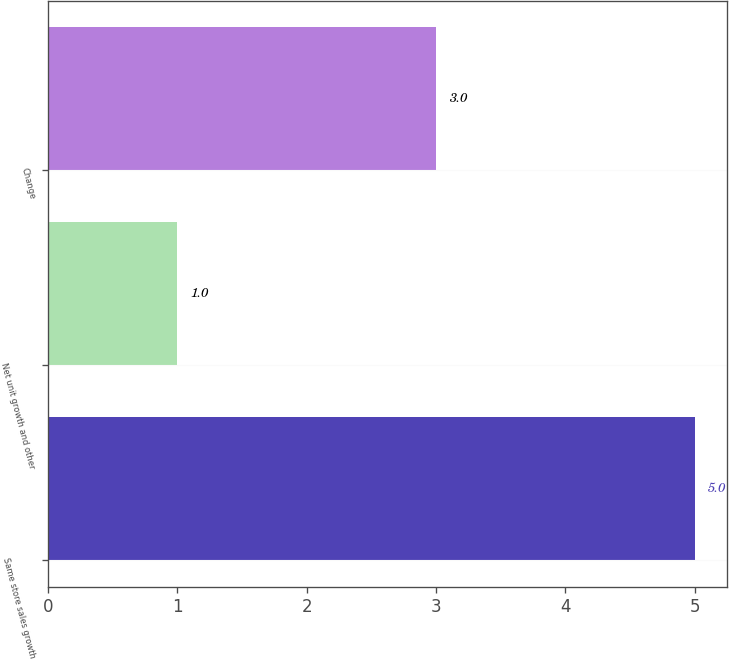Convert chart. <chart><loc_0><loc_0><loc_500><loc_500><bar_chart><fcel>Same store sales growth<fcel>Net unit growth and other<fcel>Change<nl><fcel>5<fcel>1<fcel>3<nl></chart> 